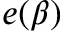Convert formula to latex. <formula><loc_0><loc_0><loc_500><loc_500>e ( \beta )</formula> 